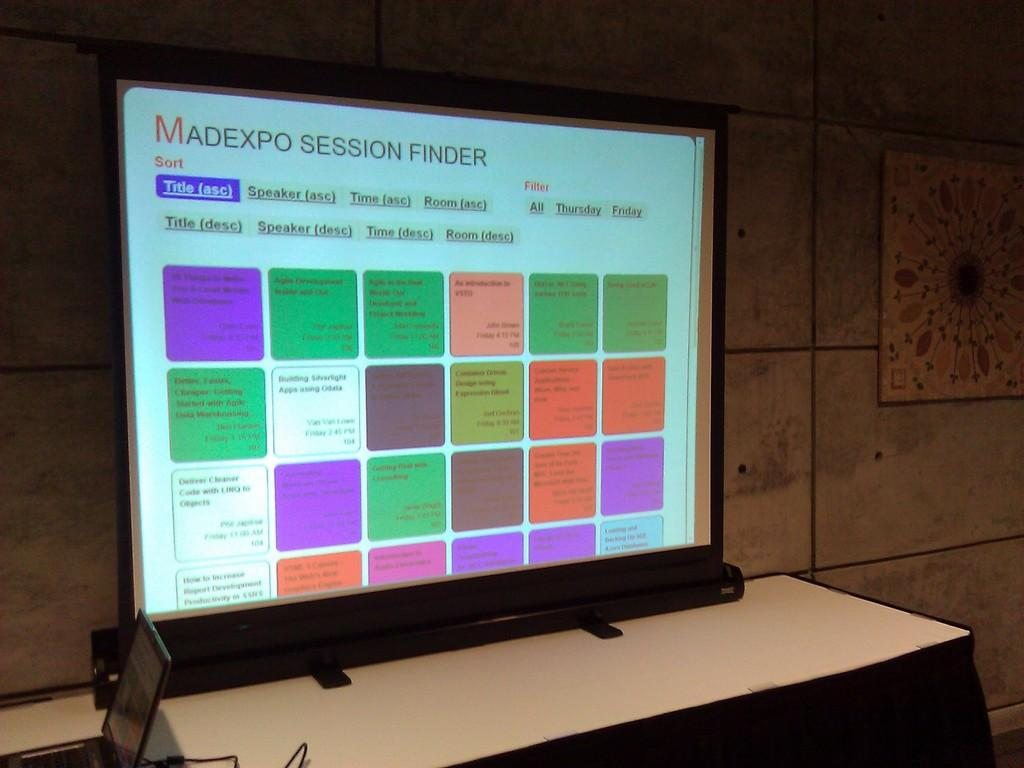<image>
Create a compact narrative representing the image presented. A computer screen with Madexpo session finder written at the top. 